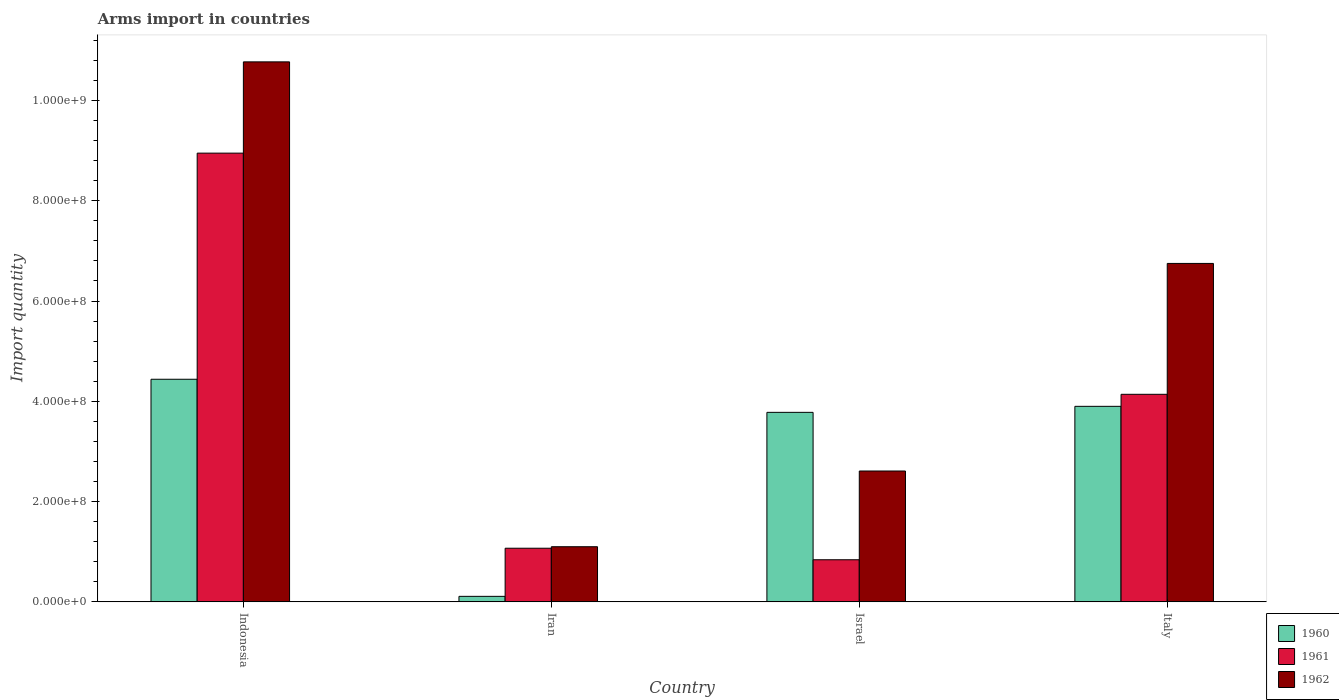How many different coloured bars are there?
Your response must be concise. 3. What is the label of the 3rd group of bars from the left?
Make the answer very short. Israel. In how many cases, is the number of bars for a given country not equal to the number of legend labels?
Your answer should be very brief. 0. What is the total arms import in 1961 in Israel?
Provide a short and direct response. 8.40e+07. Across all countries, what is the maximum total arms import in 1961?
Provide a succinct answer. 8.95e+08. Across all countries, what is the minimum total arms import in 1960?
Your response must be concise. 1.10e+07. In which country was the total arms import in 1962 minimum?
Make the answer very short. Iran. What is the total total arms import in 1961 in the graph?
Provide a succinct answer. 1.50e+09. What is the difference between the total arms import in 1962 in Indonesia and that in Israel?
Ensure brevity in your answer.  8.16e+08. What is the difference between the total arms import in 1961 in Italy and the total arms import in 1962 in Indonesia?
Offer a terse response. -6.63e+08. What is the average total arms import in 1960 per country?
Ensure brevity in your answer.  3.06e+08. What is the difference between the total arms import of/in 1961 and total arms import of/in 1960 in Iran?
Your answer should be very brief. 9.60e+07. What is the ratio of the total arms import in 1962 in Israel to that in Italy?
Your answer should be compact. 0.39. Is the difference between the total arms import in 1961 in Iran and Israel greater than the difference between the total arms import in 1960 in Iran and Israel?
Offer a terse response. Yes. What is the difference between the highest and the second highest total arms import in 1961?
Make the answer very short. 4.81e+08. What is the difference between the highest and the lowest total arms import in 1960?
Provide a succinct answer. 4.33e+08. What does the 3rd bar from the left in Israel represents?
Give a very brief answer. 1962. Are all the bars in the graph horizontal?
Keep it short and to the point. No. What is the difference between two consecutive major ticks on the Y-axis?
Offer a terse response. 2.00e+08. Are the values on the major ticks of Y-axis written in scientific E-notation?
Make the answer very short. Yes. Does the graph contain any zero values?
Give a very brief answer. No. How are the legend labels stacked?
Give a very brief answer. Vertical. What is the title of the graph?
Offer a very short reply. Arms import in countries. What is the label or title of the Y-axis?
Provide a short and direct response. Import quantity. What is the Import quantity in 1960 in Indonesia?
Offer a very short reply. 4.44e+08. What is the Import quantity in 1961 in Indonesia?
Provide a succinct answer. 8.95e+08. What is the Import quantity in 1962 in Indonesia?
Keep it short and to the point. 1.08e+09. What is the Import quantity of 1960 in Iran?
Offer a very short reply. 1.10e+07. What is the Import quantity of 1961 in Iran?
Keep it short and to the point. 1.07e+08. What is the Import quantity in 1962 in Iran?
Offer a terse response. 1.10e+08. What is the Import quantity of 1960 in Israel?
Provide a succinct answer. 3.78e+08. What is the Import quantity in 1961 in Israel?
Give a very brief answer. 8.40e+07. What is the Import quantity in 1962 in Israel?
Offer a very short reply. 2.61e+08. What is the Import quantity of 1960 in Italy?
Give a very brief answer. 3.90e+08. What is the Import quantity in 1961 in Italy?
Make the answer very short. 4.14e+08. What is the Import quantity of 1962 in Italy?
Your answer should be very brief. 6.75e+08. Across all countries, what is the maximum Import quantity of 1960?
Your response must be concise. 4.44e+08. Across all countries, what is the maximum Import quantity of 1961?
Offer a very short reply. 8.95e+08. Across all countries, what is the maximum Import quantity in 1962?
Make the answer very short. 1.08e+09. Across all countries, what is the minimum Import quantity in 1960?
Your answer should be very brief. 1.10e+07. Across all countries, what is the minimum Import quantity of 1961?
Ensure brevity in your answer.  8.40e+07. Across all countries, what is the minimum Import quantity of 1962?
Keep it short and to the point. 1.10e+08. What is the total Import quantity of 1960 in the graph?
Offer a very short reply. 1.22e+09. What is the total Import quantity in 1961 in the graph?
Your answer should be very brief. 1.50e+09. What is the total Import quantity in 1962 in the graph?
Keep it short and to the point. 2.12e+09. What is the difference between the Import quantity of 1960 in Indonesia and that in Iran?
Provide a short and direct response. 4.33e+08. What is the difference between the Import quantity of 1961 in Indonesia and that in Iran?
Ensure brevity in your answer.  7.88e+08. What is the difference between the Import quantity in 1962 in Indonesia and that in Iran?
Ensure brevity in your answer.  9.67e+08. What is the difference between the Import quantity in 1960 in Indonesia and that in Israel?
Make the answer very short. 6.60e+07. What is the difference between the Import quantity of 1961 in Indonesia and that in Israel?
Provide a short and direct response. 8.11e+08. What is the difference between the Import quantity in 1962 in Indonesia and that in Israel?
Provide a succinct answer. 8.16e+08. What is the difference between the Import quantity in 1960 in Indonesia and that in Italy?
Provide a succinct answer. 5.40e+07. What is the difference between the Import quantity in 1961 in Indonesia and that in Italy?
Offer a terse response. 4.81e+08. What is the difference between the Import quantity in 1962 in Indonesia and that in Italy?
Offer a very short reply. 4.02e+08. What is the difference between the Import quantity in 1960 in Iran and that in Israel?
Your answer should be very brief. -3.67e+08. What is the difference between the Import quantity of 1961 in Iran and that in Israel?
Make the answer very short. 2.30e+07. What is the difference between the Import quantity of 1962 in Iran and that in Israel?
Give a very brief answer. -1.51e+08. What is the difference between the Import quantity of 1960 in Iran and that in Italy?
Make the answer very short. -3.79e+08. What is the difference between the Import quantity of 1961 in Iran and that in Italy?
Your answer should be compact. -3.07e+08. What is the difference between the Import quantity in 1962 in Iran and that in Italy?
Offer a terse response. -5.65e+08. What is the difference between the Import quantity in 1960 in Israel and that in Italy?
Provide a short and direct response. -1.20e+07. What is the difference between the Import quantity in 1961 in Israel and that in Italy?
Your response must be concise. -3.30e+08. What is the difference between the Import quantity in 1962 in Israel and that in Italy?
Provide a short and direct response. -4.14e+08. What is the difference between the Import quantity of 1960 in Indonesia and the Import quantity of 1961 in Iran?
Your response must be concise. 3.37e+08. What is the difference between the Import quantity in 1960 in Indonesia and the Import quantity in 1962 in Iran?
Provide a short and direct response. 3.34e+08. What is the difference between the Import quantity in 1961 in Indonesia and the Import quantity in 1962 in Iran?
Give a very brief answer. 7.85e+08. What is the difference between the Import quantity of 1960 in Indonesia and the Import quantity of 1961 in Israel?
Offer a terse response. 3.60e+08. What is the difference between the Import quantity in 1960 in Indonesia and the Import quantity in 1962 in Israel?
Offer a terse response. 1.83e+08. What is the difference between the Import quantity of 1961 in Indonesia and the Import quantity of 1962 in Israel?
Ensure brevity in your answer.  6.34e+08. What is the difference between the Import quantity in 1960 in Indonesia and the Import quantity in 1961 in Italy?
Your response must be concise. 3.00e+07. What is the difference between the Import quantity in 1960 in Indonesia and the Import quantity in 1962 in Italy?
Offer a terse response. -2.31e+08. What is the difference between the Import quantity in 1961 in Indonesia and the Import quantity in 1962 in Italy?
Your answer should be compact. 2.20e+08. What is the difference between the Import quantity of 1960 in Iran and the Import quantity of 1961 in Israel?
Your answer should be very brief. -7.30e+07. What is the difference between the Import quantity in 1960 in Iran and the Import quantity in 1962 in Israel?
Make the answer very short. -2.50e+08. What is the difference between the Import quantity of 1961 in Iran and the Import quantity of 1962 in Israel?
Give a very brief answer. -1.54e+08. What is the difference between the Import quantity in 1960 in Iran and the Import quantity in 1961 in Italy?
Give a very brief answer. -4.03e+08. What is the difference between the Import quantity of 1960 in Iran and the Import quantity of 1962 in Italy?
Keep it short and to the point. -6.64e+08. What is the difference between the Import quantity in 1961 in Iran and the Import quantity in 1962 in Italy?
Your answer should be very brief. -5.68e+08. What is the difference between the Import quantity of 1960 in Israel and the Import quantity of 1961 in Italy?
Provide a short and direct response. -3.60e+07. What is the difference between the Import quantity in 1960 in Israel and the Import quantity in 1962 in Italy?
Offer a very short reply. -2.97e+08. What is the difference between the Import quantity of 1961 in Israel and the Import quantity of 1962 in Italy?
Provide a succinct answer. -5.91e+08. What is the average Import quantity of 1960 per country?
Your answer should be compact. 3.06e+08. What is the average Import quantity of 1961 per country?
Offer a very short reply. 3.75e+08. What is the average Import quantity in 1962 per country?
Your answer should be compact. 5.31e+08. What is the difference between the Import quantity in 1960 and Import quantity in 1961 in Indonesia?
Offer a terse response. -4.51e+08. What is the difference between the Import quantity in 1960 and Import quantity in 1962 in Indonesia?
Offer a terse response. -6.33e+08. What is the difference between the Import quantity of 1961 and Import quantity of 1962 in Indonesia?
Offer a terse response. -1.82e+08. What is the difference between the Import quantity in 1960 and Import quantity in 1961 in Iran?
Your answer should be very brief. -9.60e+07. What is the difference between the Import quantity of 1960 and Import quantity of 1962 in Iran?
Provide a succinct answer. -9.90e+07. What is the difference between the Import quantity of 1961 and Import quantity of 1962 in Iran?
Provide a succinct answer. -3.00e+06. What is the difference between the Import quantity in 1960 and Import quantity in 1961 in Israel?
Your answer should be compact. 2.94e+08. What is the difference between the Import quantity of 1960 and Import quantity of 1962 in Israel?
Your answer should be compact. 1.17e+08. What is the difference between the Import quantity in 1961 and Import quantity in 1962 in Israel?
Your answer should be very brief. -1.77e+08. What is the difference between the Import quantity of 1960 and Import quantity of 1961 in Italy?
Provide a succinct answer. -2.40e+07. What is the difference between the Import quantity in 1960 and Import quantity in 1962 in Italy?
Your response must be concise. -2.85e+08. What is the difference between the Import quantity in 1961 and Import quantity in 1962 in Italy?
Ensure brevity in your answer.  -2.61e+08. What is the ratio of the Import quantity in 1960 in Indonesia to that in Iran?
Your answer should be compact. 40.36. What is the ratio of the Import quantity in 1961 in Indonesia to that in Iran?
Provide a succinct answer. 8.36. What is the ratio of the Import quantity of 1962 in Indonesia to that in Iran?
Offer a terse response. 9.79. What is the ratio of the Import quantity in 1960 in Indonesia to that in Israel?
Offer a terse response. 1.17. What is the ratio of the Import quantity in 1961 in Indonesia to that in Israel?
Provide a succinct answer. 10.65. What is the ratio of the Import quantity of 1962 in Indonesia to that in Israel?
Provide a short and direct response. 4.13. What is the ratio of the Import quantity in 1960 in Indonesia to that in Italy?
Your answer should be compact. 1.14. What is the ratio of the Import quantity in 1961 in Indonesia to that in Italy?
Provide a short and direct response. 2.16. What is the ratio of the Import quantity in 1962 in Indonesia to that in Italy?
Provide a succinct answer. 1.6. What is the ratio of the Import quantity in 1960 in Iran to that in Israel?
Offer a terse response. 0.03. What is the ratio of the Import quantity of 1961 in Iran to that in Israel?
Your response must be concise. 1.27. What is the ratio of the Import quantity of 1962 in Iran to that in Israel?
Offer a terse response. 0.42. What is the ratio of the Import quantity of 1960 in Iran to that in Italy?
Make the answer very short. 0.03. What is the ratio of the Import quantity in 1961 in Iran to that in Italy?
Provide a succinct answer. 0.26. What is the ratio of the Import quantity in 1962 in Iran to that in Italy?
Ensure brevity in your answer.  0.16. What is the ratio of the Import quantity in 1960 in Israel to that in Italy?
Provide a succinct answer. 0.97. What is the ratio of the Import quantity in 1961 in Israel to that in Italy?
Your answer should be compact. 0.2. What is the ratio of the Import quantity of 1962 in Israel to that in Italy?
Provide a succinct answer. 0.39. What is the difference between the highest and the second highest Import quantity in 1960?
Give a very brief answer. 5.40e+07. What is the difference between the highest and the second highest Import quantity of 1961?
Ensure brevity in your answer.  4.81e+08. What is the difference between the highest and the second highest Import quantity of 1962?
Offer a terse response. 4.02e+08. What is the difference between the highest and the lowest Import quantity of 1960?
Your response must be concise. 4.33e+08. What is the difference between the highest and the lowest Import quantity in 1961?
Offer a terse response. 8.11e+08. What is the difference between the highest and the lowest Import quantity in 1962?
Your answer should be very brief. 9.67e+08. 